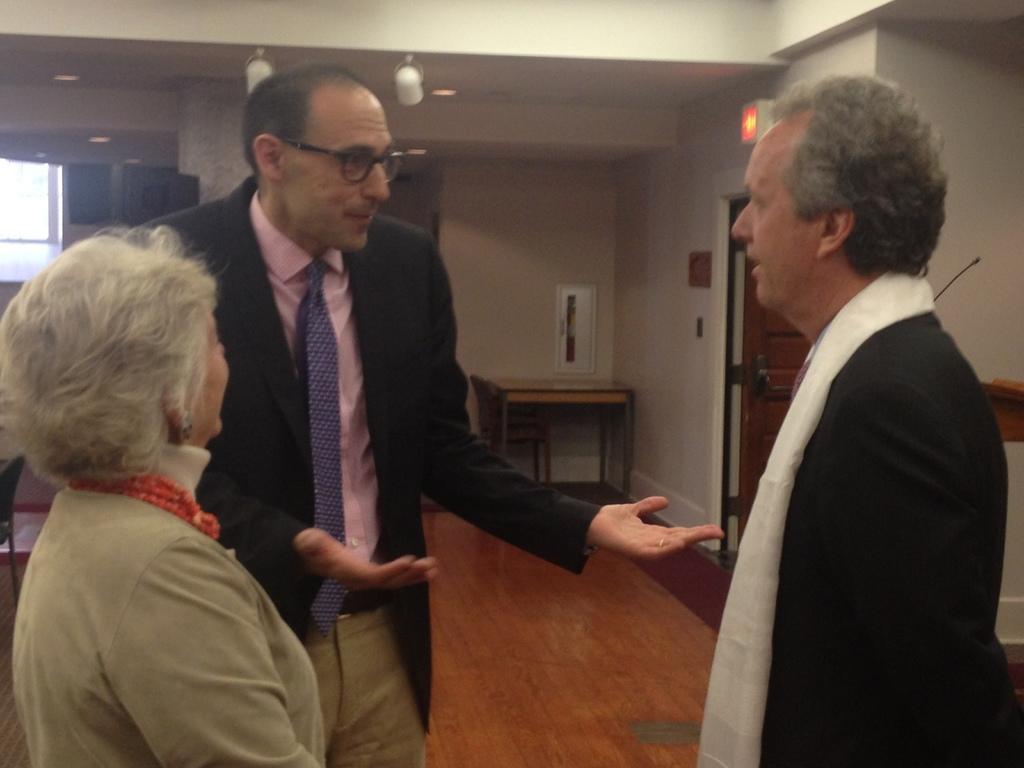How would you summarize this image in a sentence or two? In the picture I can see three persons standing and there are few other objects in the background. 